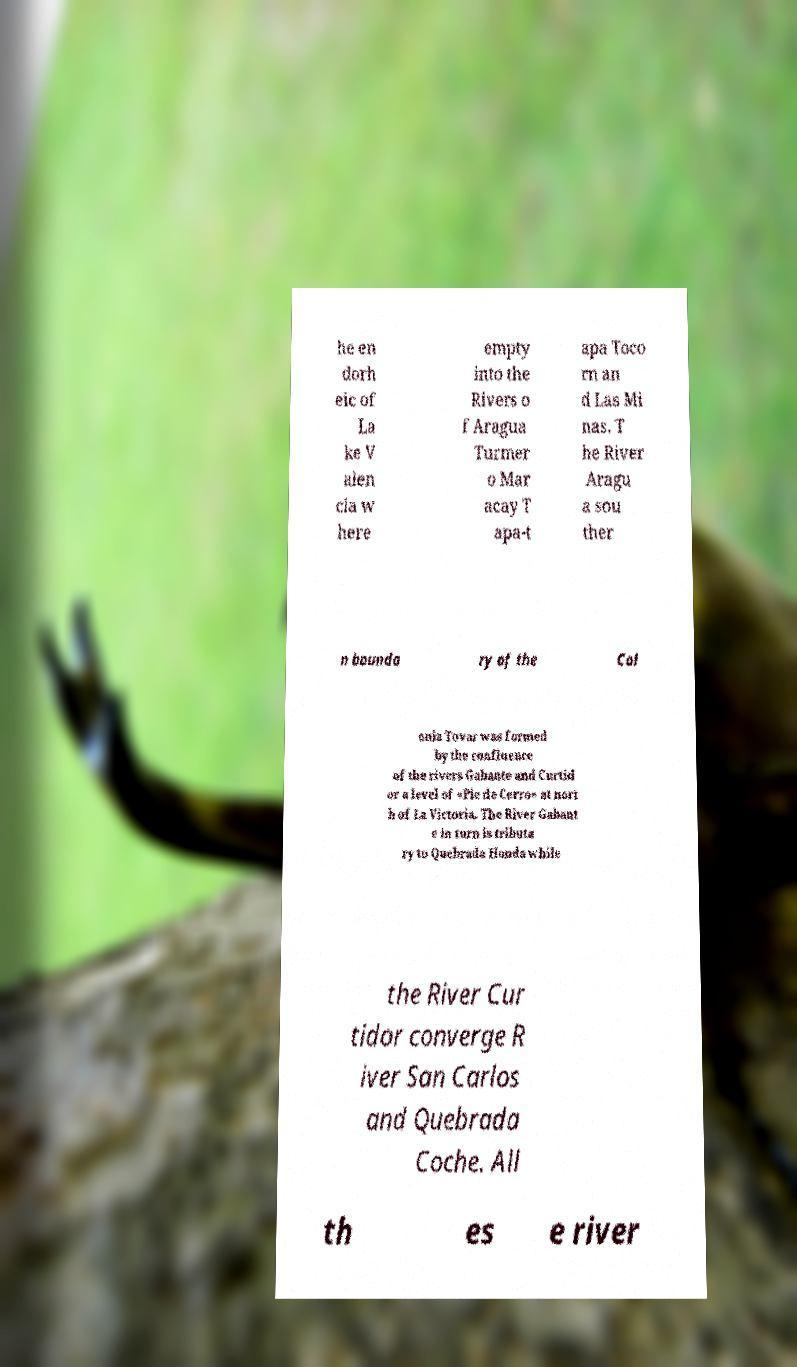I need the written content from this picture converted into text. Can you do that? he en dorh eic of La ke V alen cia w here empty into the Rivers o f Aragua Turmer o Mar acay T apa-t apa Toco rn an d Las Mi nas. T he River Aragu a sou ther n bounda ry of the Col onia Tovar was formed by the confluence of the rivers Gabante and Curtid or a level of «Pie de Cerro» at nort h of La Victoria. The River Gabant e in turn is tributa ry to Quebrada Honda while the River Cur tidor converge R iver San Carlos and Quebrada Coche. All th es e river 